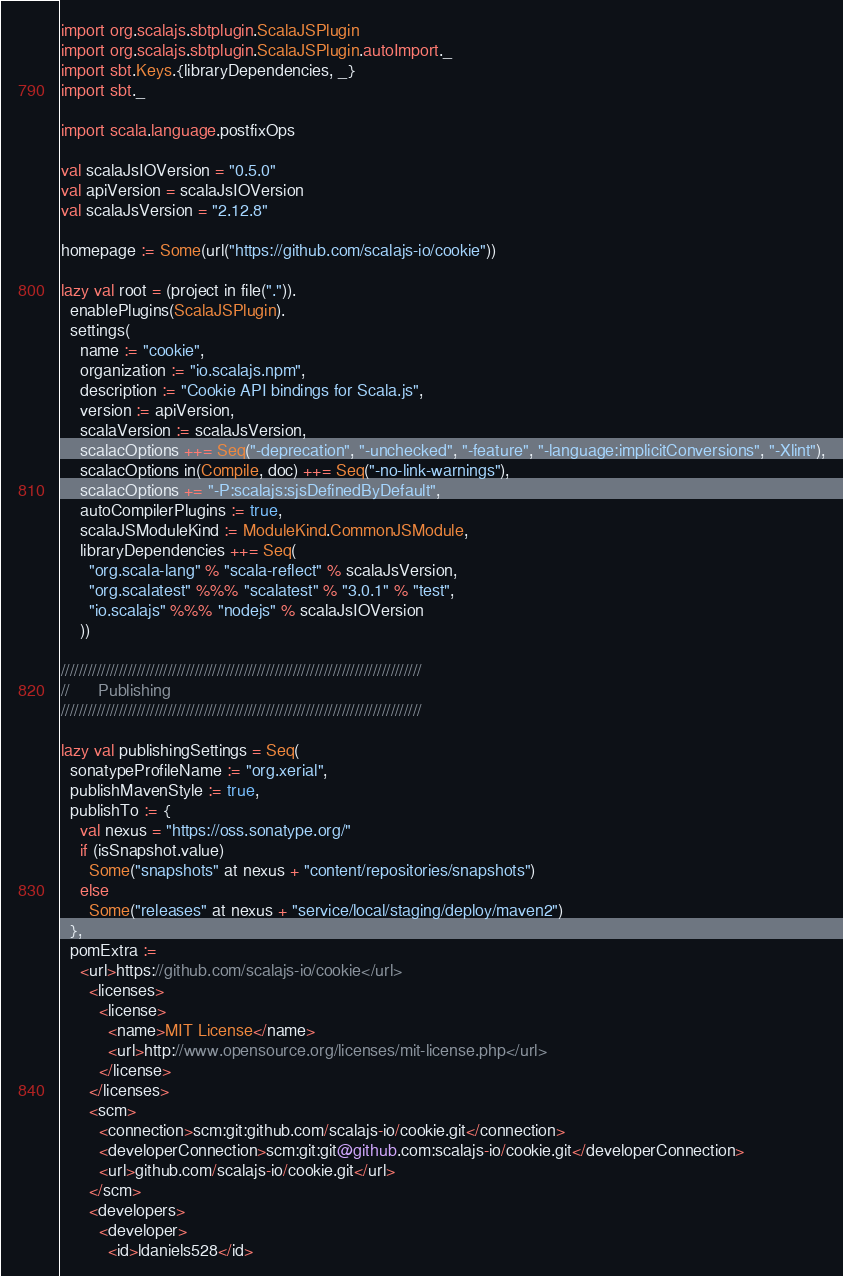<code> <loc_0><loc_0><loc_500><loc_500><_Scala_>import org.scalajs.sbtplugin.ScalaJSPlugin
import org.scalajs.sbtplugin.ScalaJSPlugin.autoImport._
import sbt.Keys.{libraryDependencies, _}
import sbt._

import scala.language.postfixOps

val scalaJsIOVersion = "0.5.0"
val apiVersion = scalaJsIOVersion
val scalaJsVersion = "2.12.8"

homepage := Some(url("https://github.com/scalajs-io/cookie"))

lazy val root = (project in file(".")).
  enablePlugins(ScalaJSPlugin).
  settings(
    name := "cookie",
    organization := "io.scalajs.npm",
    description := "Cookie API bindings for Scala.js",
    version := apiVersion,
    scalaVersion := scalaJsVersion,
    scalacOptions ++= Seq("-deprecation", "-unchecked", "-feature", "-language:implicitConversions", "-Xlint"),
    scalacOptions in(Compile, doc) ++= Seq("-no-link-warnings"),
    scalacOptions += "-P:scalajs:sjsDefinedByDefault",
    autoCompilerPlugins := true,
    scalaJSModuleKind := ModuleKind.CommonJSModule,
    libraryDependencies ++= Seq(
      "org.scala-lang" % "scala-reflect" % scalaJsVersion,
      "org.scalatest" %%% "scalatest" % "3.0.1" % "test",
      "io.scalajs" %%% "nodejs" % scalaJsIOVersion
    ))

/////////////////////////////////////////////////////////////////////////////////
//      Publishing
/////////////////////////////////////////////////////////////////////////////////

lazy val publishingSettings = Seq(
  sonatypeProfileName := "org.xerial",
  publishMavenStyle := true,
  publishTo := {
    val nexus = "https://oss.sonatype.org/"
    if (isSnapshot.value)
      Some("snapshots" at nexus + "content/repositories/snapshots")
    else
      Some("releases" at nexus + "service/local/staging/deploy/maven2")
  },
  pomExtra :=
    <url>https://github.com/scalajs-io/cookie</url>
      <licenses>
        <license>
          <name>MIT License</name>
          <url>http://www.opensource.org/licenses/mit-license.php</url>
        </license>
      </licenses>
      <scm>
        <connection>scm:git:github.com/scalajs-io/cookie.git</connection>
        <developerConnection>scm:git:git@github.com:scalajs-io/cookie.git</developerConnection>
        <url>github.com/scalajs-io/cookie.git</url>
      </scm>
      <developers>
        <developer>
          <id>ldaniels528</id></code> 